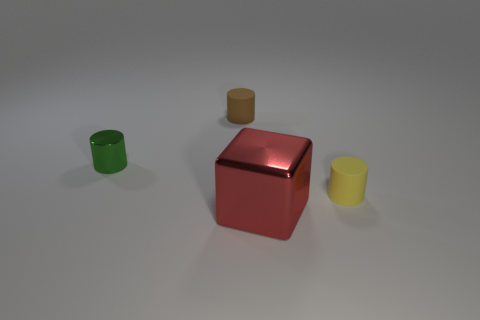There is a small yellow thing that is made of the same material as the brown thing; what is its shape?
Provide a succinct answer. Cylinder. Is the material of the green cylinder that is behind the big metallic cube the same as the tiny brown cylinder?
Offer a very short reply. No. Do the small thing right of the small brown cylinder and the tiny matte cylinder that is on the left side of the big red thing have the same color?
Give a very brief answer. No. How many things are left of the small yellow matte thing and to the right of the brown matte thing?
Ensure brevity in your answer.  1. What is the brown cylinder made of?
Make the answer very short. Rubber. What shape is the other metallic object that is the same size as the yellow object?
Offer a terse response. Cylinder. Is the thing in front of the small yellow matte cylinder made of the same material as the tiny green object that is left of the metal cube?
Ensure brevity in your answer.  Yes. How many brown rubber things are there?
Keep it short and to the point. 1. How many tiny yellow matte objects are the same shape as the tiny brown matte object?
Offer a terse response. 1. Does the tiny yellow rubber object have the same shape as the brown matte thing?
Make the answer very short. Yes. 